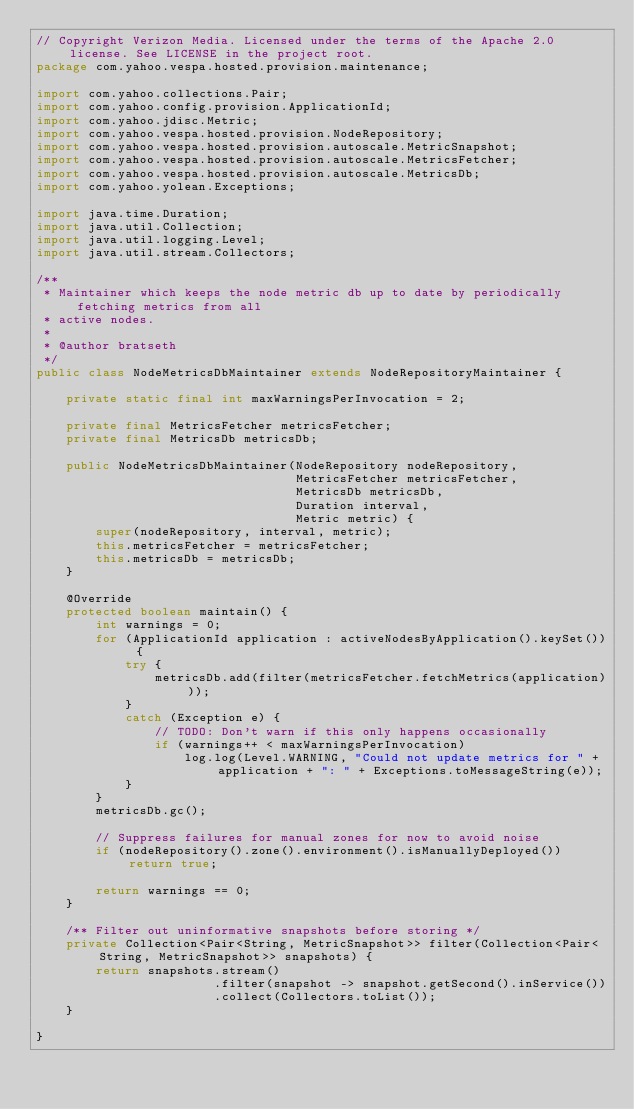Convert code to text. <code><loc_0><loc_0><loc_500><loc_500><_Java_>// Copyright Verizon Media. Licensed under the terms of the Apache 2.0 license. See LICENSE in the project root.
package com.yahoo.vespa.hosted.provision.maintenance;

import com.yahoo.collections.Pair;
import com.yahoo.config.provision.ApplicationId;
import com.yahoo.jdisc.Metric;
import com.yahoo.vespa.hosted.provision.NodeRepository;
import com.yahoo.vespa.hosted.provision.autoscale.MetricSnapshot;
import com.yahoo.vespa.hosted.provision.autoscale.MetricsFetcher;
import com.yahoo.vespa.hosted.provision.autoscale.MetricsDb;
import com.yahoo.yolean.Exceptions;

import java.time.Duration;
import java.util.Collection;
import java.util.logging.Level;
import java.util.stream.Collectors;

/**
 * Maintainer which keeps the node metric db up to date by periodically fetching metrics from all
 * active nodes.
 *
 * @author bratseth
 */
public class NodeMetricsDbMaintainer extends NodeRepositoryMaintainer {

    private static final int maxWarningsPerInvocation = 2;

    private final MetricsFetcher metricsFetcher;
    private final MetricsDb metricsDb;

    public NodeMetricsDbMaintainer(NodeRepository nodeRepository,
                                   MetricsFetcher metricsFetcher,
                                   MetricsDb metricsDb,
                                   Duration interval,
                                   Metric metric) {
        super(nodeRepository, interval, metric);
        this.metricsFetcher = metricsFetcher;
        this.metricsDb = metricsDb;
    }

    @Override
    protected boolean maintain() {
        int warnings = 0;
        for (ApplicationId application : activeNodesByApplication().keySet()) {
            try {
                metricsDb.add(filter(metricsFetcher.fetchMetrics(application)));
            }
            catch (Exception e) {
                // TODO: Don't warn if this only happens occasionally
                if (warnings++ < maxWarningsPerInvocation)
                    log.log(Level.WARNING, "Could not update metrics for " + application + ": " + Exceptions.toMessageString(e));
            }
        }
        metricsDb.gc();

        // Suppress failures for manual zones for now to avoid noise
        if (nodeRepository().zone().environment().isManuallyDeployed()) return true;

        return warnings == 0;
    }

    /** Filter out uninformative snapshots before storing */
    private Collection<Pair<String, MetricSnapshot>> filter(Collection<Pair<String, MetricSnapshot>> snapshots) {
        return snapshots.stream()
                        .filter(snapshot -> snapshot.getSecond().inService())
                        .collect(Collectors.toList());
    }

}
</code> 